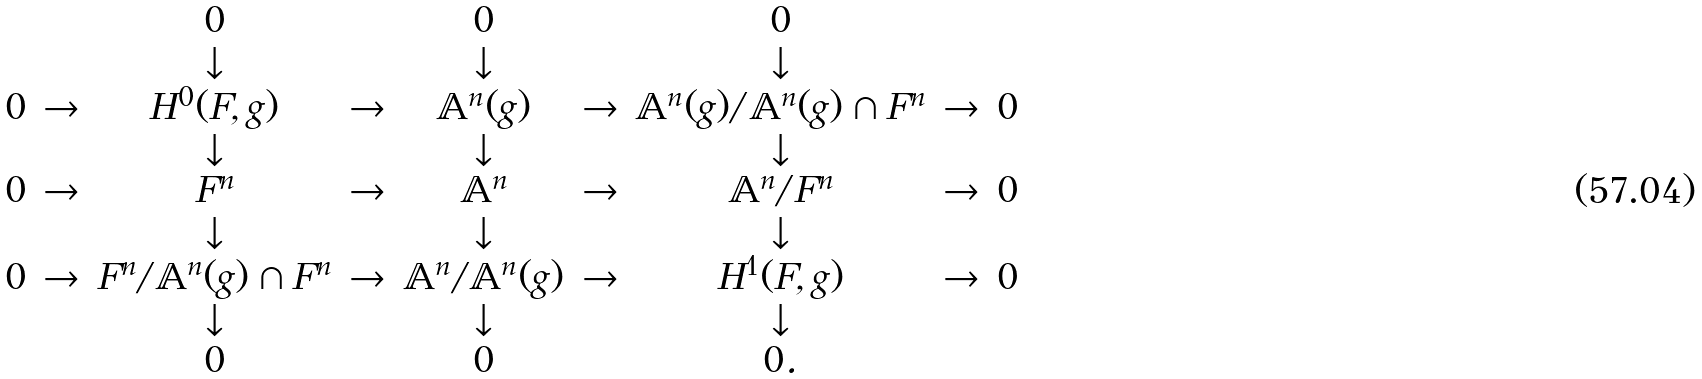Convert formula to latex. <formula><loc_0><loc_0><loc_500><loc_500>\begin{matrix} & & 0 & & 0 & & 0 & & \\ & & \downarrow & & \downarrow & & \downarrow & & \\ 0 & \to & H ^ { 0 } ( F , g ) & \to & \mathbb { A } ^ { n } ( g ) & \to & \mathbb { A } ^ { n } ( g ) / \mathbb { A } ^ { n } ( g ) \cap F ^ { n } & \to & 0 \\ & & \downarrow & & \downarrow & & \downarrow & & \\ 0 & \to & F ^ { n } & \to & \mathbb { A } ^ { n } & \to & \mathbb { A } ^ { n } / F ^ { n } & \to & 0 \\ & & \downarrow & & \downarrow & & \downarrow & & \\ 0 & \to & F ^ { n } / \mathbb { A } ^ { n } ( g ) \cap F ^ { n } & \to & \mathbb { A } ^ { n } / \mathbb { A } ^ { n } ( g ) & \to & H ^ { 1 } ( F , g ) & \to & 0 \\ & & \downarrow & & \downarrow & & \downarrow & & \\ & & 0 & & 0 & & 0 . & & \end{matrix}</formula> 